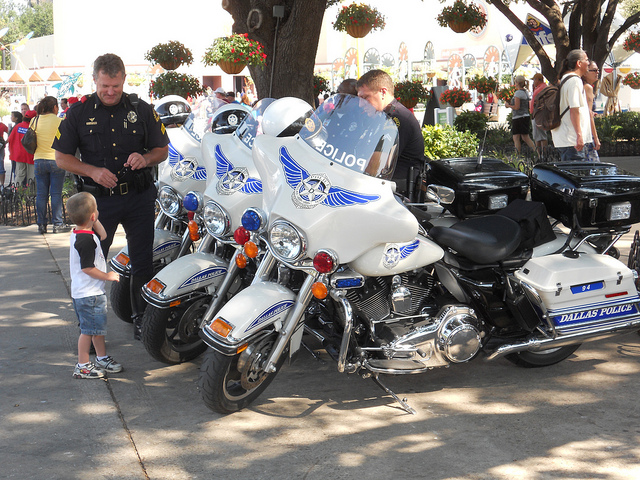Please identify all text content in this image. POLICE DALLAS POLICE 